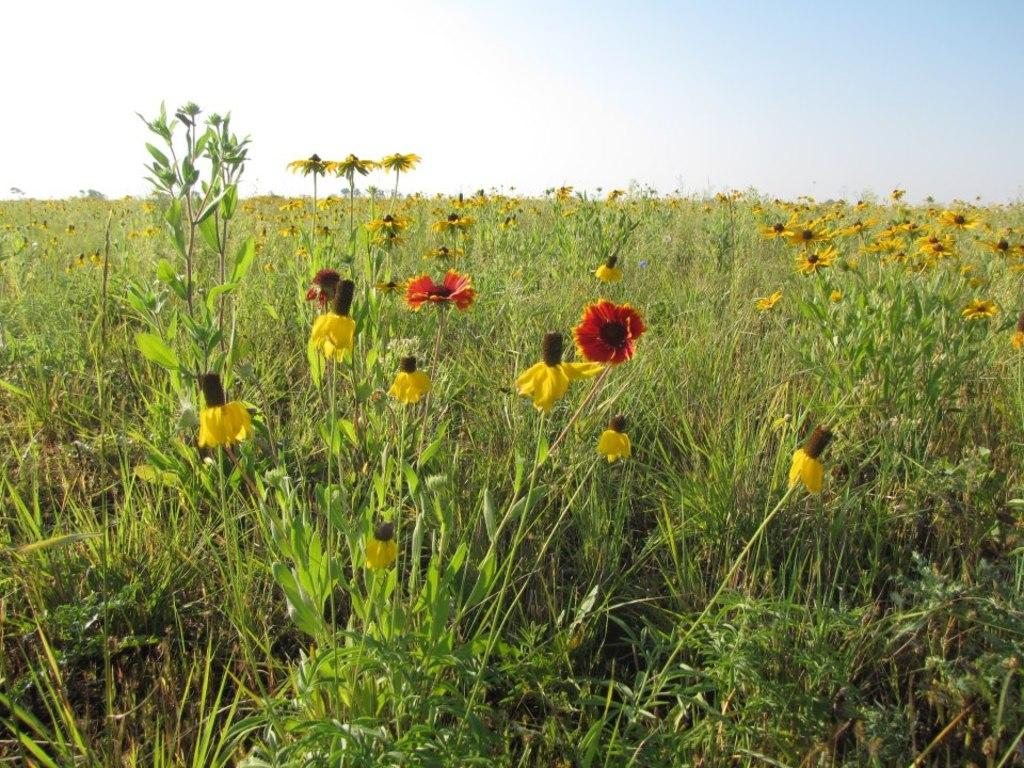What is the main subject of the image? The main subject of the image is a flower field. Can you describe the setting of the image? The image features a field filled with flowers. What is the weight of the brick in the flower field? There is no brick present in the image, so it is not possible to determine its weight. 